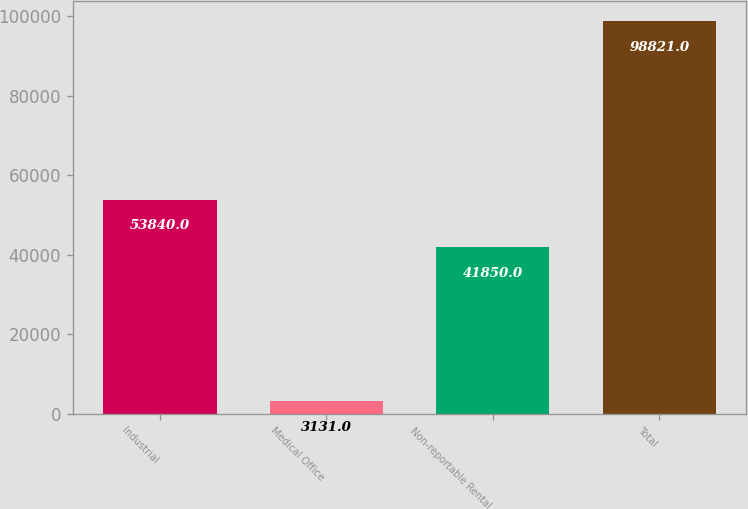Convert chart. <chart><loc_0><loc_0><loc_500><loc_500><bar_chart><fcel>Industrial<fcel>Medical Office<fcel>Non-reportable Rental<fcel>Total<nl><fcel>53840<fcel>3131<fcel>41850<fcel>98821<nl></chart> 